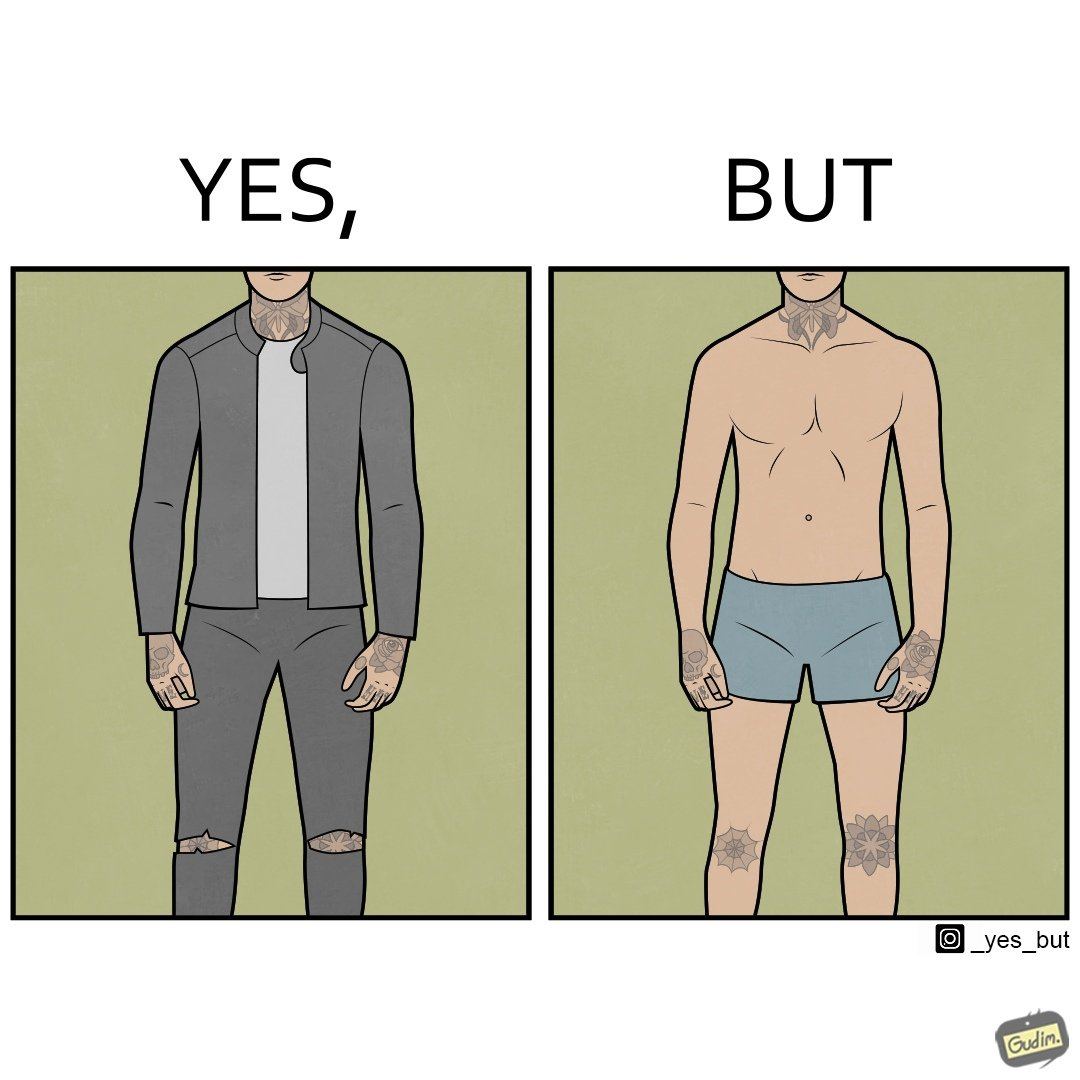What makes this image funny or satirical? The images are funny since it shows a man with tattoos on his exposed body parts in normal clothing gives the illusion that he has tattoos all over his body, but in reality, he has tattoos only on those few parts. 